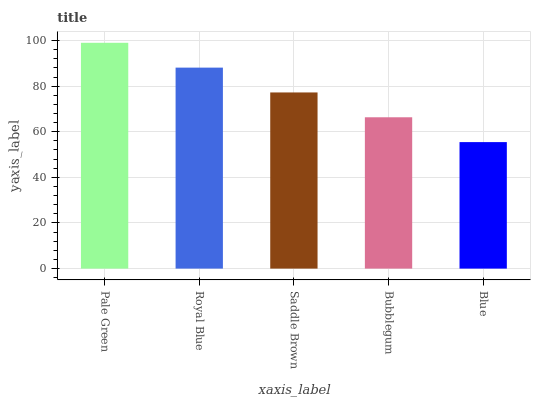Is Blue the minimum?
Answer yes or no. Yes. Is Pale Green the maximum?
Answer yes or no. Yes. Is Royal Blue the minimum?
Answer yes or no. No. Is Royal Blue the maximum?
Answer yes or no. No. Is Pale Green greater than Royal Blue?
Answer yes or no. Yes. Is Royal Blue less than Pale Green?
Answer yes or no. Yes. Is Royal Blue greater than Pale Green?
Answer yes or no. No. Is Pale Green less than Royal Blue?
Answer yes or no. No. Is Saddle Brown the high median?
Answer yes or no. Yes. Is Saddle Brown the low median?
Answer yes or no. Yes. Is Bubblegum the high median?
Answer yes or no. No. Is Pale Green the low median?
Answer yes or no. No. 